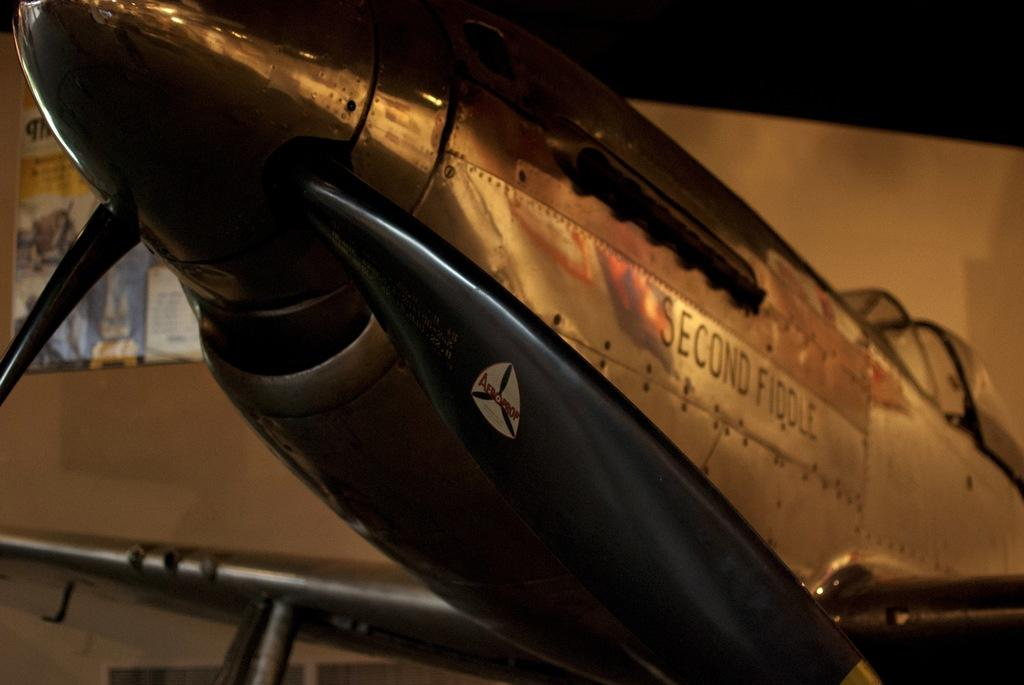<image>
Summarize the visual content of the image. An old front end of a propeller fighter plane has Second Fiddle on its side. 